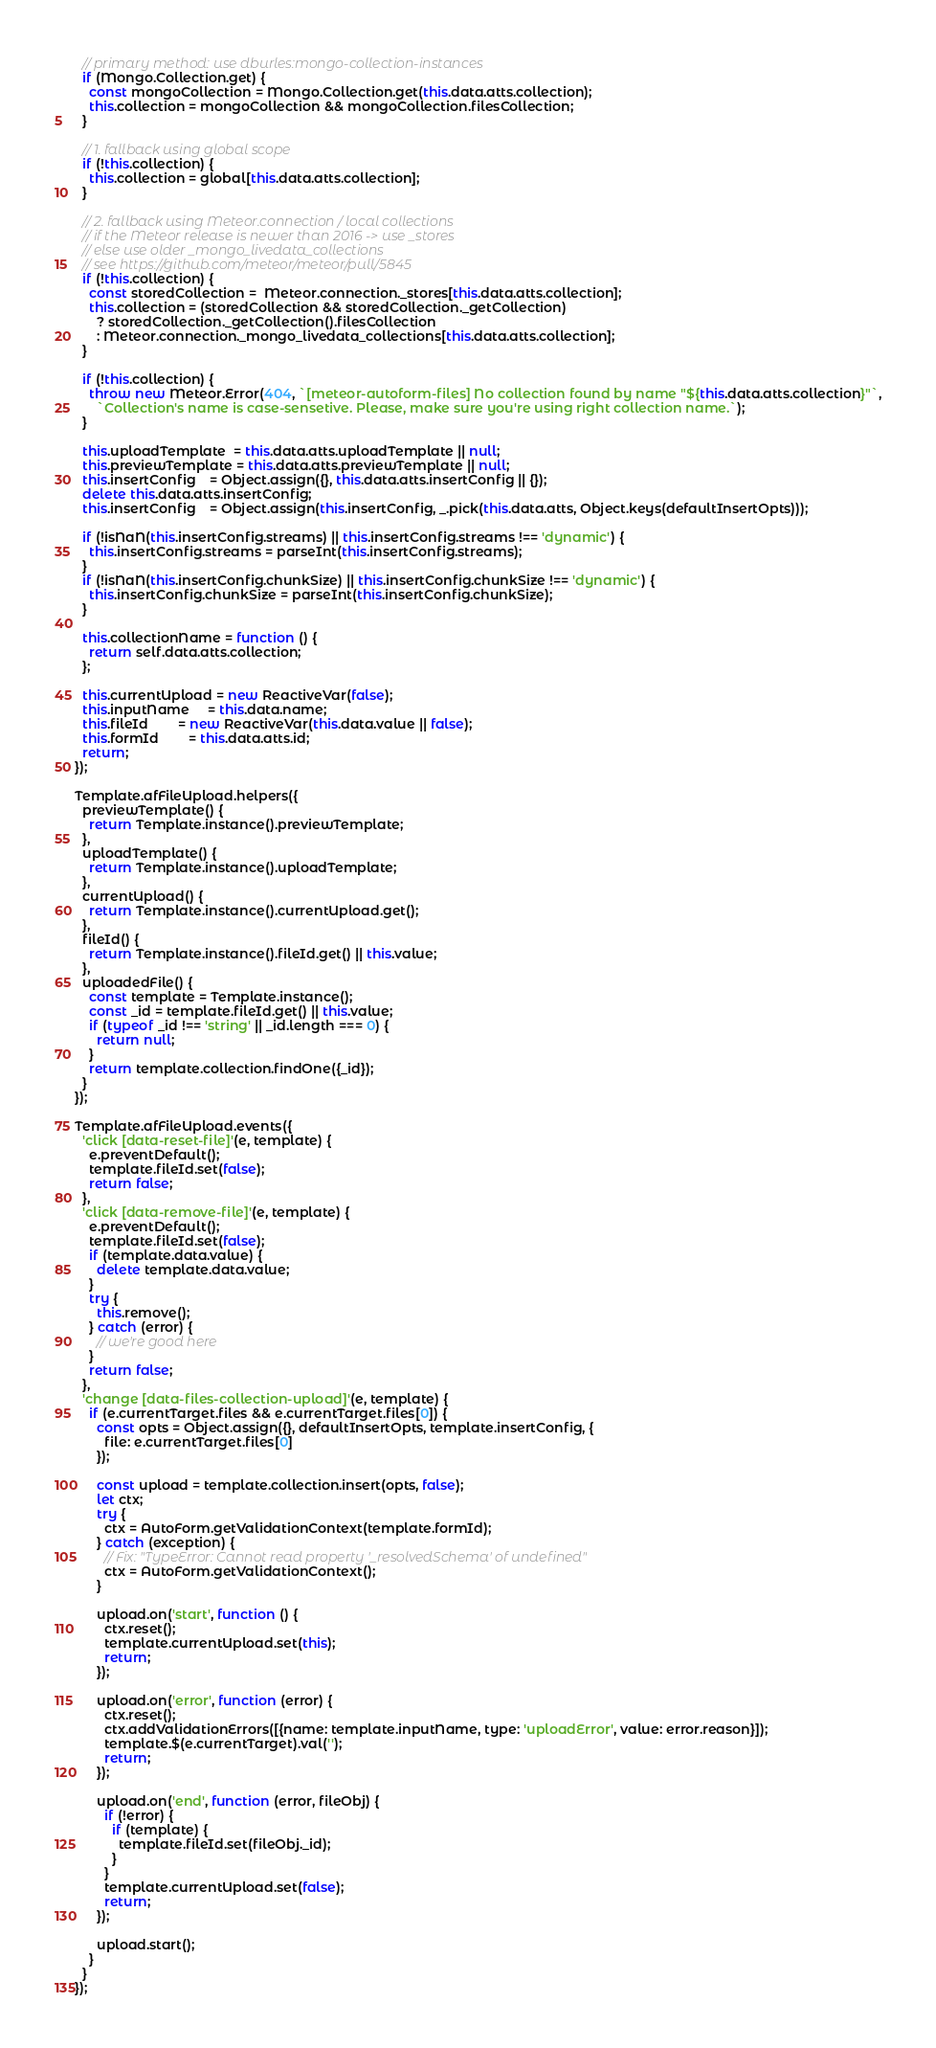Convert code to text. <code><loc_0><loc_0><loc_500><loc_500><_JavaScript_>  // primary method: use dburles:mongo-collection-instances
  if (Mongo.Collection.get) {
    const mongoCollection = Mongo.Collection.get(this.data.atts.collection);
    this.collection = mongoCollection && mongoCollection.filesCollection;
  }

  // 1. fallback using global scope
  if (!this.collection) {
    this.collection = global[this.data.atts.collection];
  }

  // 2. fallback using Meteor.connection / local collections
  // if the Meteor release is newer than 2016 -> use _stores
  // else use older _mongo_livedata_collections
  // see https://github.com/meteor/meteor/pull/5845
  if (!this.collection) {
    const storedCollection =  Meteor.connection._stores[this.data.atts.collection];
    this.collection = (storedCollection && storedCollection._getCollection)
      ? storedCollection._getCollection().filesCollection
      : Meteor.connection._mongo_livedata_collections[this.data.atts.collection];
  }

  if (!this.collection) {
    throw new Meteor.Error(404, `[meteor-autoform-files] No collection found by name "${this.data.atts.collection}"`,
      `Collection's name is case-sensetive. Please, make sure you're using right collection name.`);
  }

  this.uploadTemplate  = this.data.atts.uploadTemplate || null;
  this.previewTemplate = this.data.atts.previewTemplate || null;
  this.insertConfig    = Object.assign({}, this.data.atts.insertConfig || {});
  delete this.data.atts.insertConfig;
  this.insertConfig    = Object.assign(this.insertConfig, _.pick(this.data.atts, Object.keys(defaultInsertOpts)));

  if (!isNaN(this.insertConfig.streams) || this.insertConfig.streams !== 'dynamic') {
    this.insertConfig.streams = parseInt(this.insertConfig.streams);
  }
  if (!isNaN(this.insertConfig.chunkSize) || this.insertConfig.chunkSize !== 'dynamic') {
    this.insertConfig.chunkSize = parseInt(this.insertConfig.chunkSize);
  }

  this.collectionName = function () {
    return self.data.atts.collection;
  };

  this.currentUpload = new ReactiveVar(false);
  this.inputName     = this.data.name;
  this.fileId        = new ReactiveVar(this.data.value || false);
  this.formId        = this.data.atts.id;
  return;
});

Template.afFileUpload.helpers({
  previewTemplate() {
    return Template.instance().previewTemplate;
  },
  uploadTemplate() {
    return Template.instance().uploadTemplate;
  },
  currentUpload() {
    return Template.instance().currentUpload.get();
  },
  fileId() {
    return Template.instance().fileId.get() || this.value;
  },
  uploadedFile() {
    const template = Template.instance();
    const _id = template.fileId.get() || this.value;
    if (typeof _id !== 'string' || _id.length === 0) {
      return null;
    }
    return template.collection.findOne({_id});
  }
});

Template.afFileUpload.events({
  'click [data-reset-file]'(e, template) {
    e.preventDefault();
    template.fileId.set(false);
    return false;
  },
  'click [data-remove-file]'(e, template) {
    e.preventDefault();
    template.fileId.set(false);
    if (template.data.value) {
      delete template.data.value;
    }
    try {
      this.remove();
    } catch (error) {
      // we're good here
    }
    return false;
  },
  'change [data-files-collection-upload]'(e, template) {
    if (e.currentTarget.files && e.currentTarget.files[0]) {
      const opts = Object.assign({}, defaultInsertOpts, template.insertConfig, {
        file: e.currentTarget.files[0]
      });

      const upload = template.collection.insert(opts, false);
      let ctx;
      try {
        ctx = AutoForm.getValidationContext(template.formId);
      } catch (exception) {
        // Fix: "TypeError: Cannot read property '_resolvedSchema' of undefined"
        ctx = AutoForm.getValidationContext();
      }

      upload.on('start', function () {
        ctx.reset();
        template.currentUpload.set(this);
        return;
      });

      upload.on('error', function (error) {
        ctx.reset();
        ctx.addValidationErrors([{name: template.inputName, type: 'uploadError', value: error.reason}]);
        template.$(e.currentTarget).val('');
        return;
      });

      upload.on('end', function (error, fileObj) {
        if (!error) {
          if (template) {
            template.fileId.set(fileObj._id);
          }
        }
        template.currentUpload.set(false);
        return;
      });

      upload.start();
    }
  }
});
</code> 